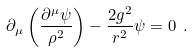Convert formula to latex. <formula><loc_0><loc_0><loc_500><loc_500>\partial _ { \mu } \left ( \frac { \partial ^ { \mu } \psi } { \rho ^ { 2 } } \right ) - \frac { 2 g ^ { 2 } } { r ^ { 2 } } \psi = 0 \ .</formula> 